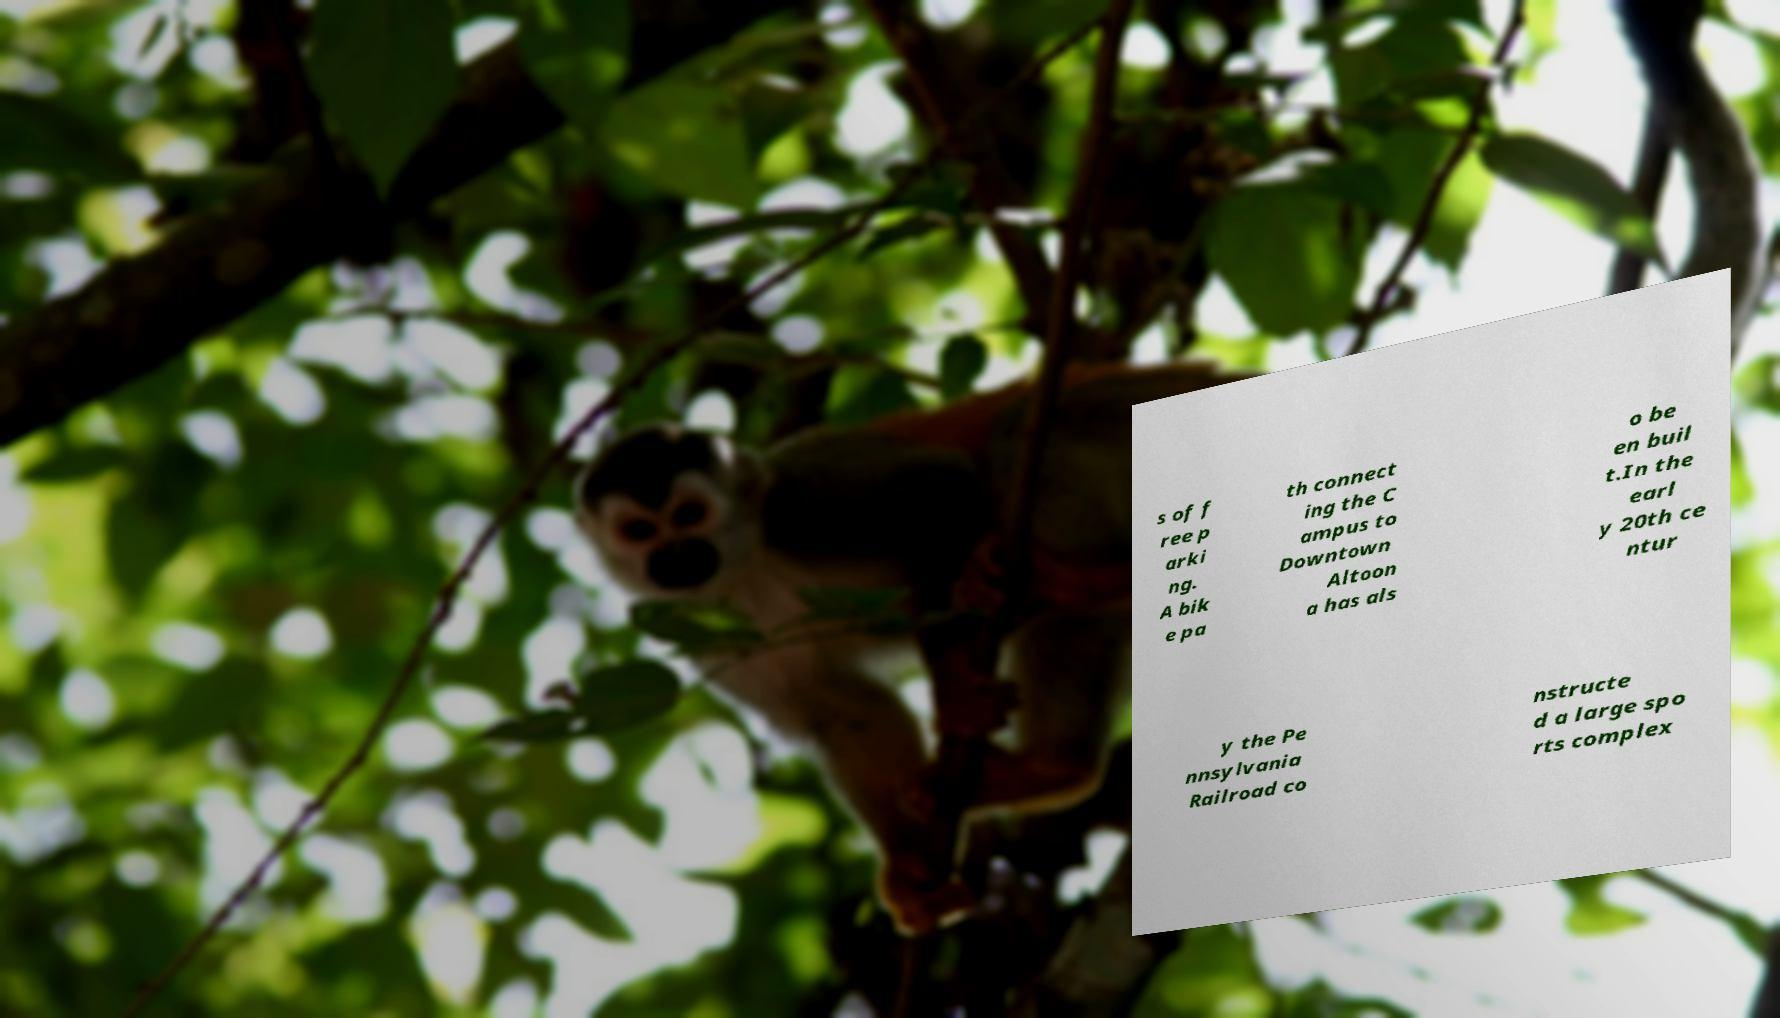Can you read and provide the text displayed in the image?This photo seems to have some interesting text. Can you extract and type it out for me? s of f ree p arki ng. A bik e pa th connect ing the C ampus to Downtown Altoon a has als o be en buil t.In the earl y 20th ce ntur y the Pe nnsylvania Railroad co nstructe d a large spo rts complex 